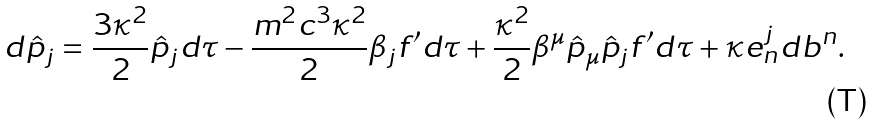<formula> <loc_0><loc_0><loc_500><loc_500>d \hat { p } _ { j } = \frac { 3 \kappa ^ { 2 } } { 2 } \hat { p } _ { j } d \tau - \frac { m ^ { 2 } c ^ { 3 } \kappa ^ { 2 } } { 2 } \beta _ { j } f ^ { \prime } d \tau + \frac { \kappa ^ { 2 } } { 2 } \beta ^ { \mu } \hat { p } _ { \mu } \hat { p } _ { j } f ^ { \prime } d \tau + \kappa e ^ { j } _ { n } d b ^ { n } .</formula> 